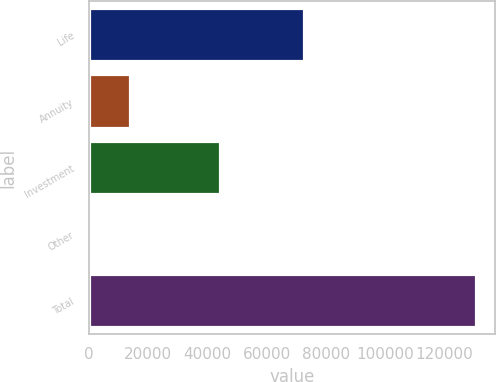Convert chart. <chart><loc_0><loc_0><loc_500><loc_500><bar_chart><fcel>Life<fcel>Annuity<fcel>Investment<fcel>Other<fcel>Total<nl><fcel>72585<fcel>13771<fcel>44289<fcel>3.89<fcel>130645<nl></chart> 